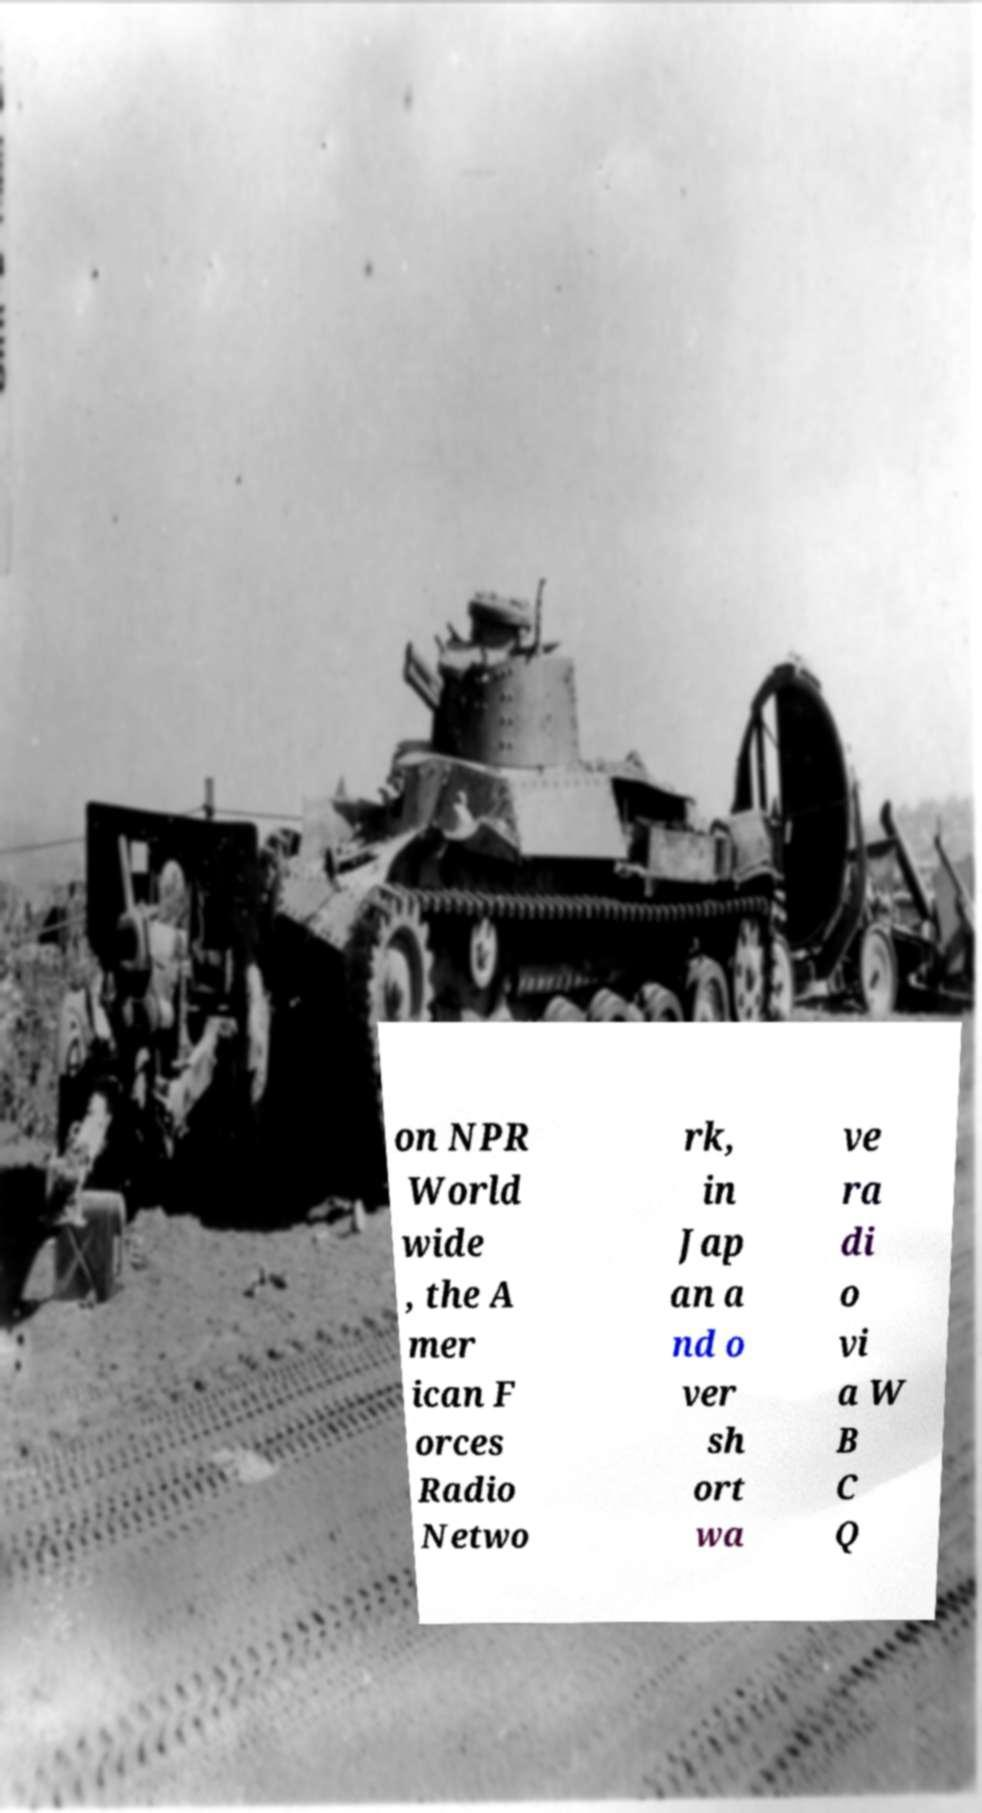Please identify and transcribe the text found in this image. on NPR World wide , the A mer ican F orces Radio Netwo rk, in Jap an a nd o ver sh ort wa ve ra di o vi a W B C Q 